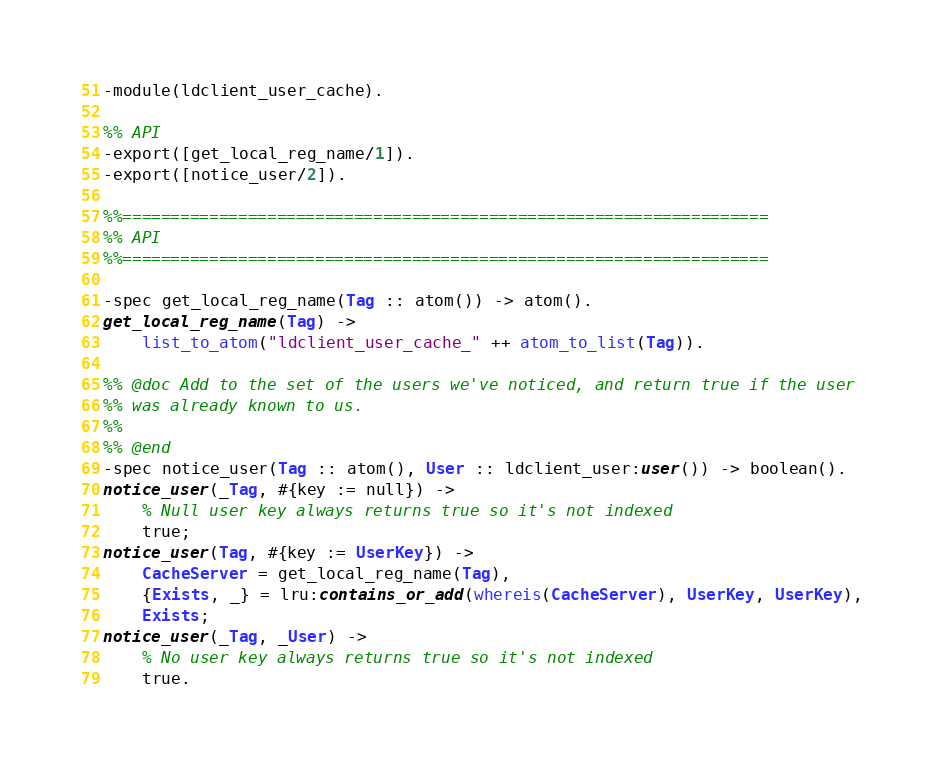Convert code to text. <code><loc_0><loc_0><loc_500><loc_500><_Erlang_>
-module(ldclient_user_cache).

%% API
-export([get_local_reg_name/1]).
-export([notice_user/2]).

%%===================================================================
%% API
%%===================================================================

-spec get_local_reg_name(Tag :: atom()) -> atom().
get_local_reg_name(Tag) ->
    list_to_atom("ldclient_user_cache_" ++ atom_to_list(Tag)).

%% @doc Add to the set of the users we've noticed, and return true if the user
%% was already known to us.
%%
%% @end
-spec notice_user(Tag :: atom(), User :: ldclient_user:user()) -> boolean().
notice_user(_Tag, #{key := null}) ->
    % Null user key always returns true so it's not indexed
    true;
notice_user(Tag, #{key := UserKey}) ->
    CacheServer = get_local_reg_name(Tag),
    {Exists, _} = lru:contains_or_add(whereis(CacheServer), UserKey, UserKey),
    Exists;
notice_user(_Tag, _User) ->
    % No user key always returns true so it's not indexed
    true.
</code> 